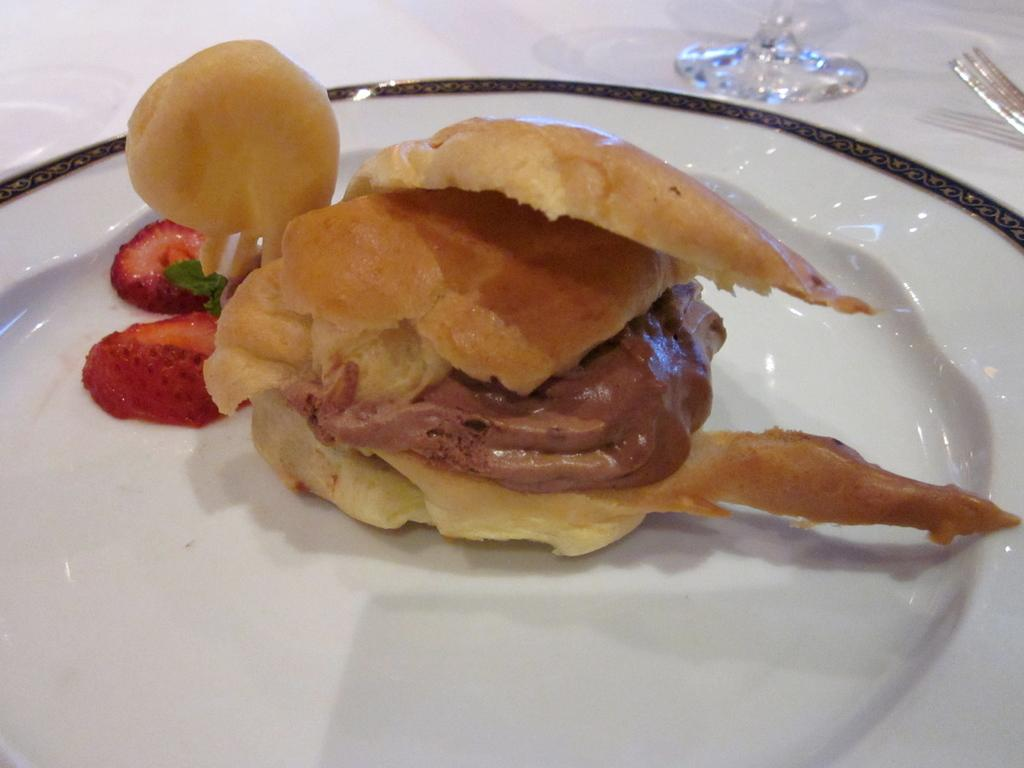What is the main subject of the image? The main subject of the image is food. What can be seen under the food in the image? The food is on a white color plate. What is the other object made of glass in the image? There is a glass in the image. What utensil is present in the image? There is a fork in the image. What is the color of the surface on which the plate, glass, and fork are placed? The plate, glass, and fork are on a white color surface. Can you tell me how many spots are on the fork in the image? There are no spots on the fork in the image; it is a smooth utensil. What type of cup is visible in the image? There is no cup present in the image. 